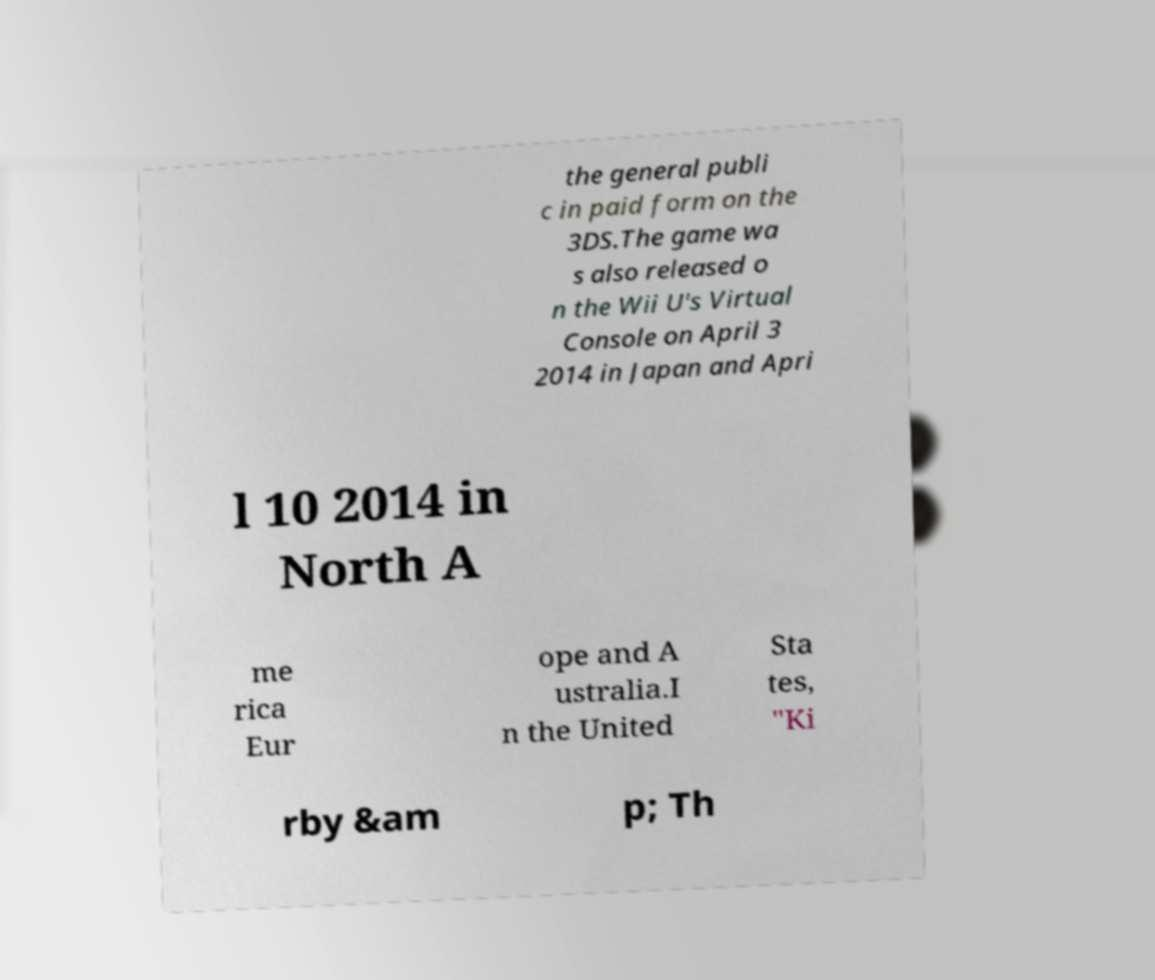For documentation purposes, I need the text within this image transcribed. Could you provide that? the general publi c in paid form on the 3DS.The game wa s also released o n the Wii U's Virtual Console on April 3 2014 in Japan and Apri l 10 2014 in North A me rica Eur ope and A ustralia.I n the United Sta tes, "Ki rby &am p; Th 